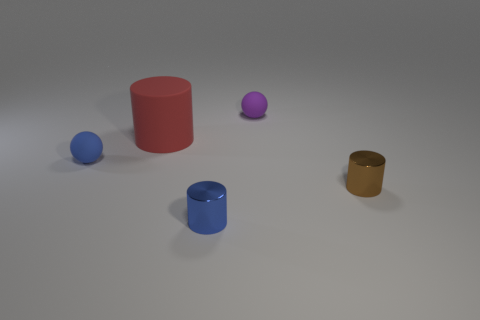Subtract all small cylinders. How many cylinders are left? 1 Add 2 red cylinders. How many objects exist? 7 Subtract all blue balls. How many balls are left? 1 Subtract all balls. How many objects are left? 3 Subtract 1 cylinders. How many cylinders are left? 2 Subtract all purple balls. Subtract all gray cylinders. How many balls are left? 1 Subtract all big things. Subtract all blue spheres. How many objects are left? 3 Add 5 brown things. How many brown things are left? 6 Add 4 small yellow objects. How many small yellow objects exist? 4 Subtract 0 gray cubes. How many objects are left? 5 